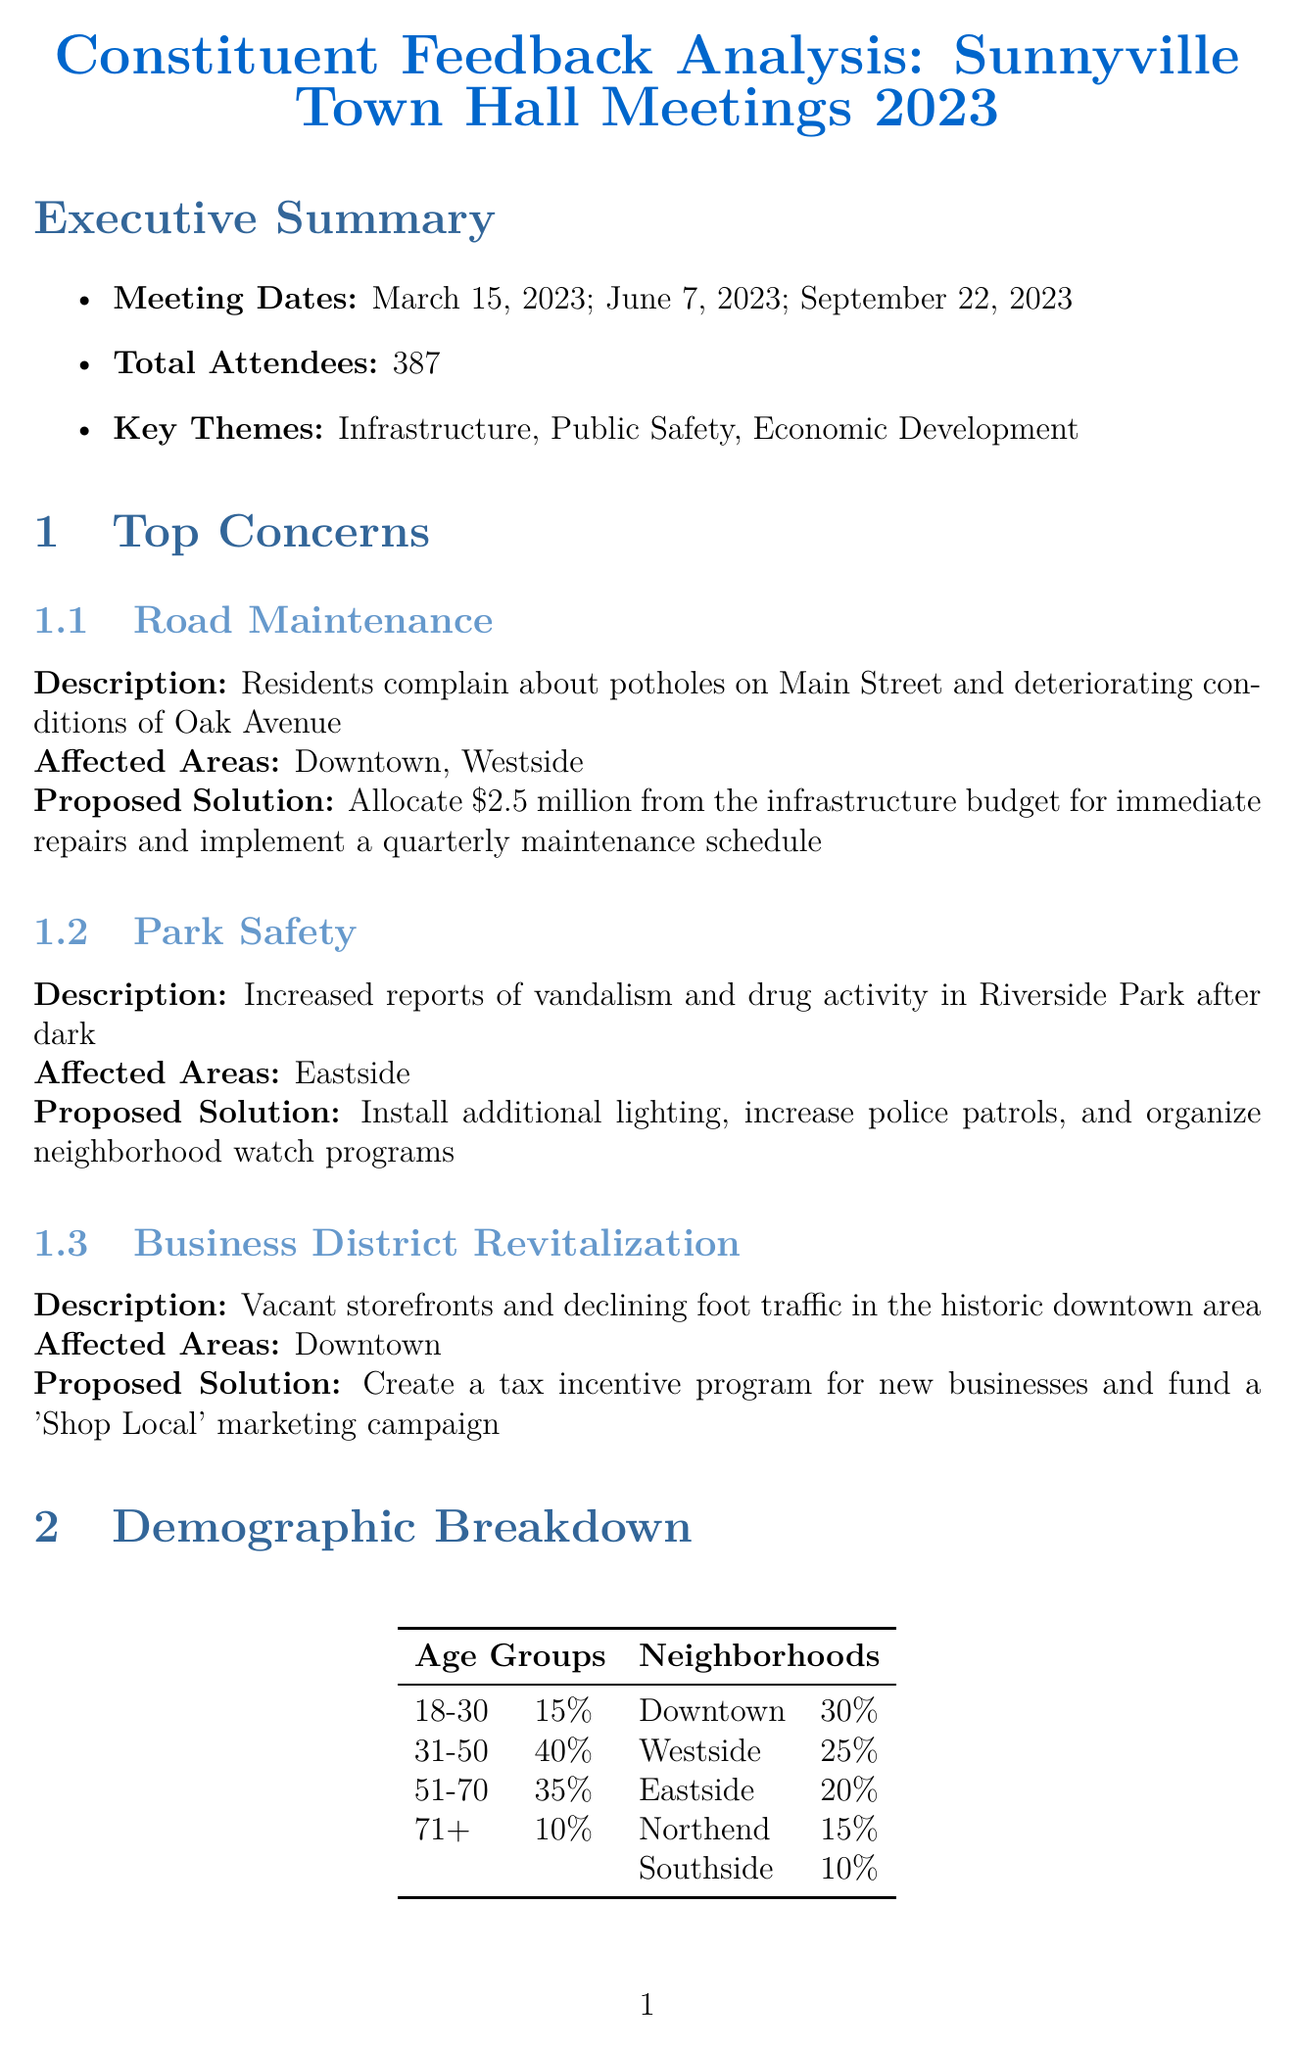What are the total attendees at the town hall meetings? The total attendance is mentioned in the executive summary of the report, which states the total attendees are 387.
Answer: 387 Which issue had concerns about deteriorating conditions? The issue specifically describing deteriorating conditions is Road Maintenance, as per the top concerns listed in the report.
Answer: Road Maintenance What is the proposed solution for Park Safety? The proposed solution for Park Safety includes several measures, one being to install additional lighting as mentioned in the top concerns section.
Answer: Install additional lighting What is the estimated total cost for addressing top concerns? The estimated total cost is stated under Budget Implications and is $5.7 million.
Answer: $5.7 million Who are the supportive council members? Supportive council members are listed in the political considerations section, which includes Sarah Johnson and Michael Chen.
Answer: Sarah Johnson, Michael Chen When is the next council meeting scheduled? The next council meeting is mentioned in the next steps section with a date of October 12, 2023.
Answer: October 12, 2023 What is the main theme of the constituent feedback? The key themes identified in the executive summary include Infrastructure, Public Safety, and Economic Development.
Answer: Infrastructure, Public Safety, Economic Development How many neighborhoods are described in the demographic breakdown? The demographic breakdown includes five neighborhoods listed in the report.
Answer: Five What will be sought through an online survey? The online survey aims to seek additional public input, as outlined in the next steps.
Answer: Additional public input 